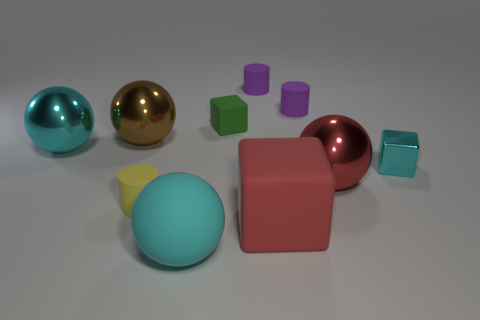Subtract 1 cylinders. How many cylinders are left? 2 Subtract all brown spheres. How many spheres are left? 3 Subtract all big matte spheres. How many spheres are left? 3 Subtract all blue spheres. Subtract all blue cylinders. How many spheres are left? 4 Subtract all cylinders. How many objects are left? 7 Subtract 0 gray cubes. How many objects are left? 10 Subtract all cylinders. Subtract all cyan shiny things. How many objects are left? 5 Add 6 big cyan things. How many big cyan things are left? 8 Add 4 large red matte balls. How many large red matte balls exist? 4 